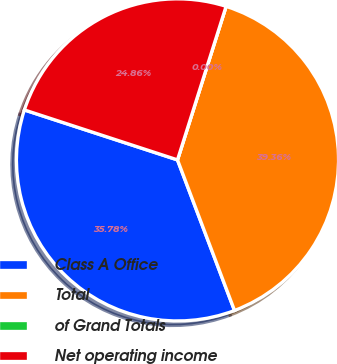Convert chart to OTSL. <chart><loc_0><loc_0><loc_500><loc_500><pie_chart><fcel>Class A Office<fcel>Total<fcel>of Grand Totals<fcel>Net operating income<nl><fcel>35.78%<fcel>39.36%<fcel>0.0%<fcel>24.86%<nl></chart> 